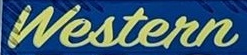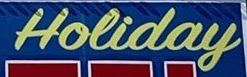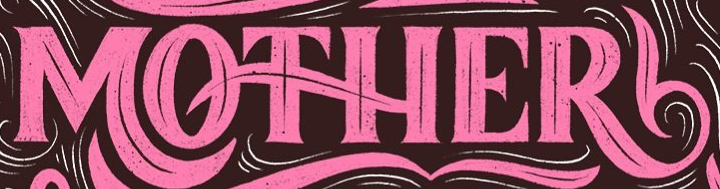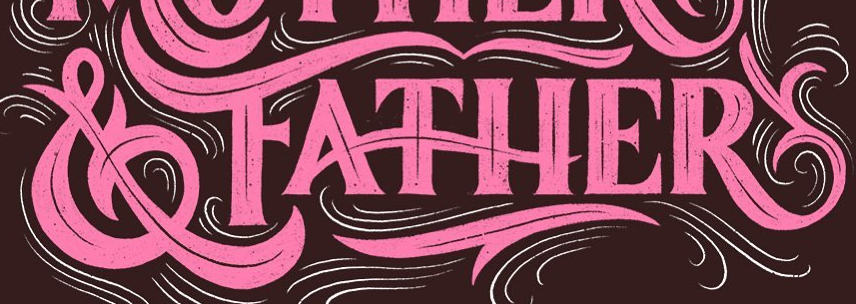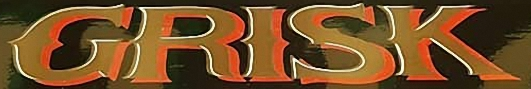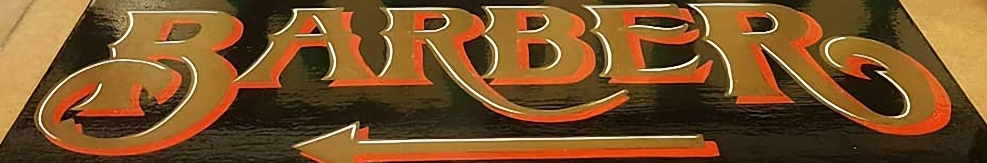What text appears in these images from left to right, separated by a semicolon? Western; Holiday; MOTHER; &FATHER; GRISK; BARBER 